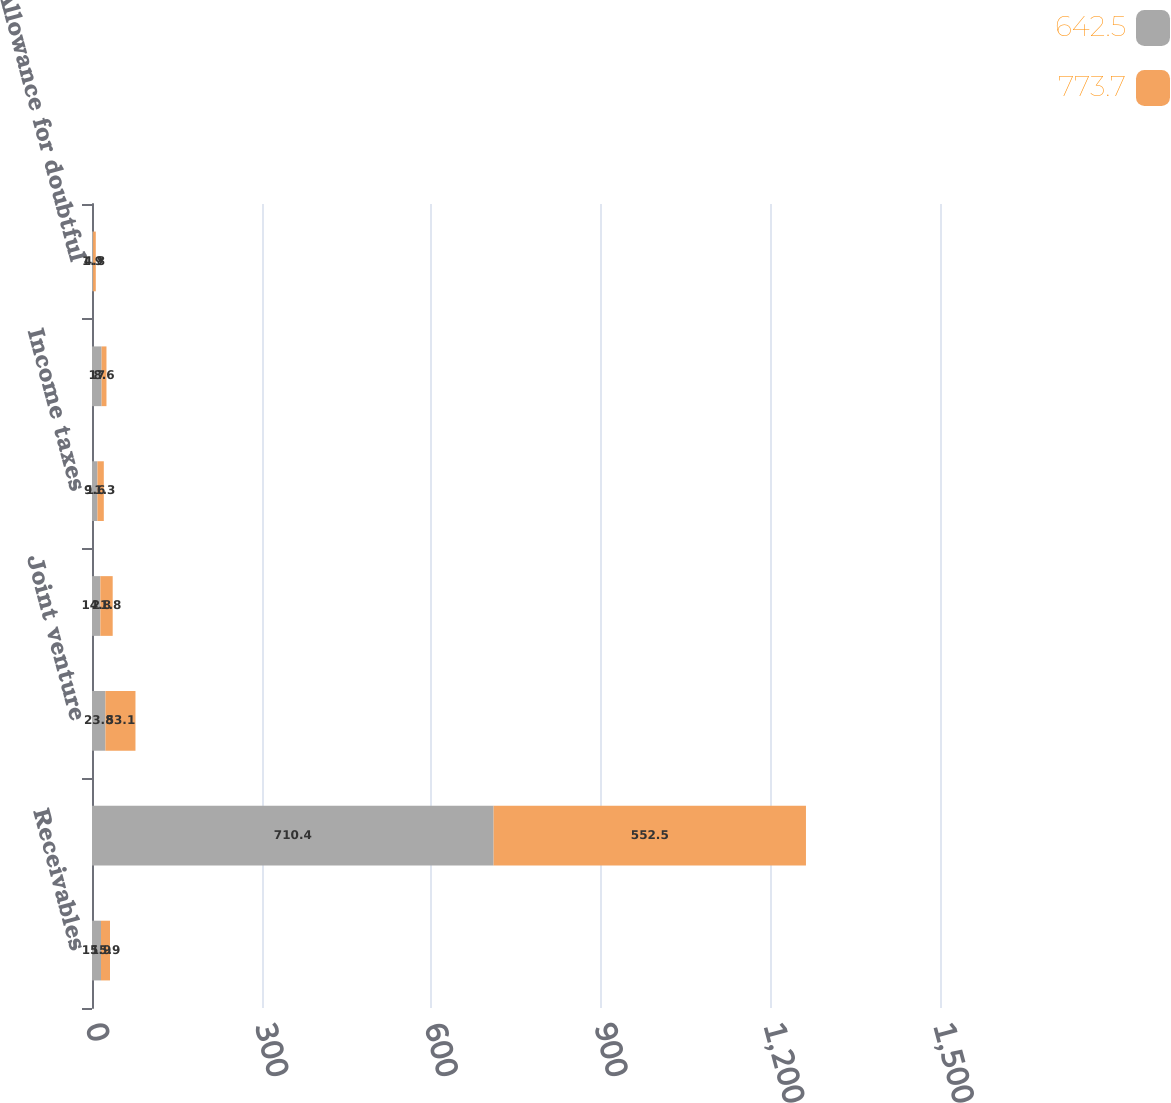<chart> <loc_0><loc_0><loc_500><loc_500><stacked_bar_chart><ecel><fcel>Receivables<fcel>Trade receivables<fcel>Joint venture<fcel>Taxes other than income<fcel>Income taxes<fcel>Other<fcel>Allowance for doubtful<nl><fcel>642.5<fcel>15.9<fcel>710.4<fcel>23.8<fcel>14.8<fcel>9.6<fcel>17<fcel>1.9<nl><fcel>773.7<fcel>15.9<fcel>552.5<fcel>53.1<fcel>21.8<fcel>11.3<fcel>8.6<fcel>4.8<nl></chart> 